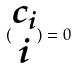Convert formula to latex. <formula><loc_0><loc_0><loc_500><loc_500>( \begin{matrix} c _ { i } \\ i \end{matrix} ) = 0</formula> 